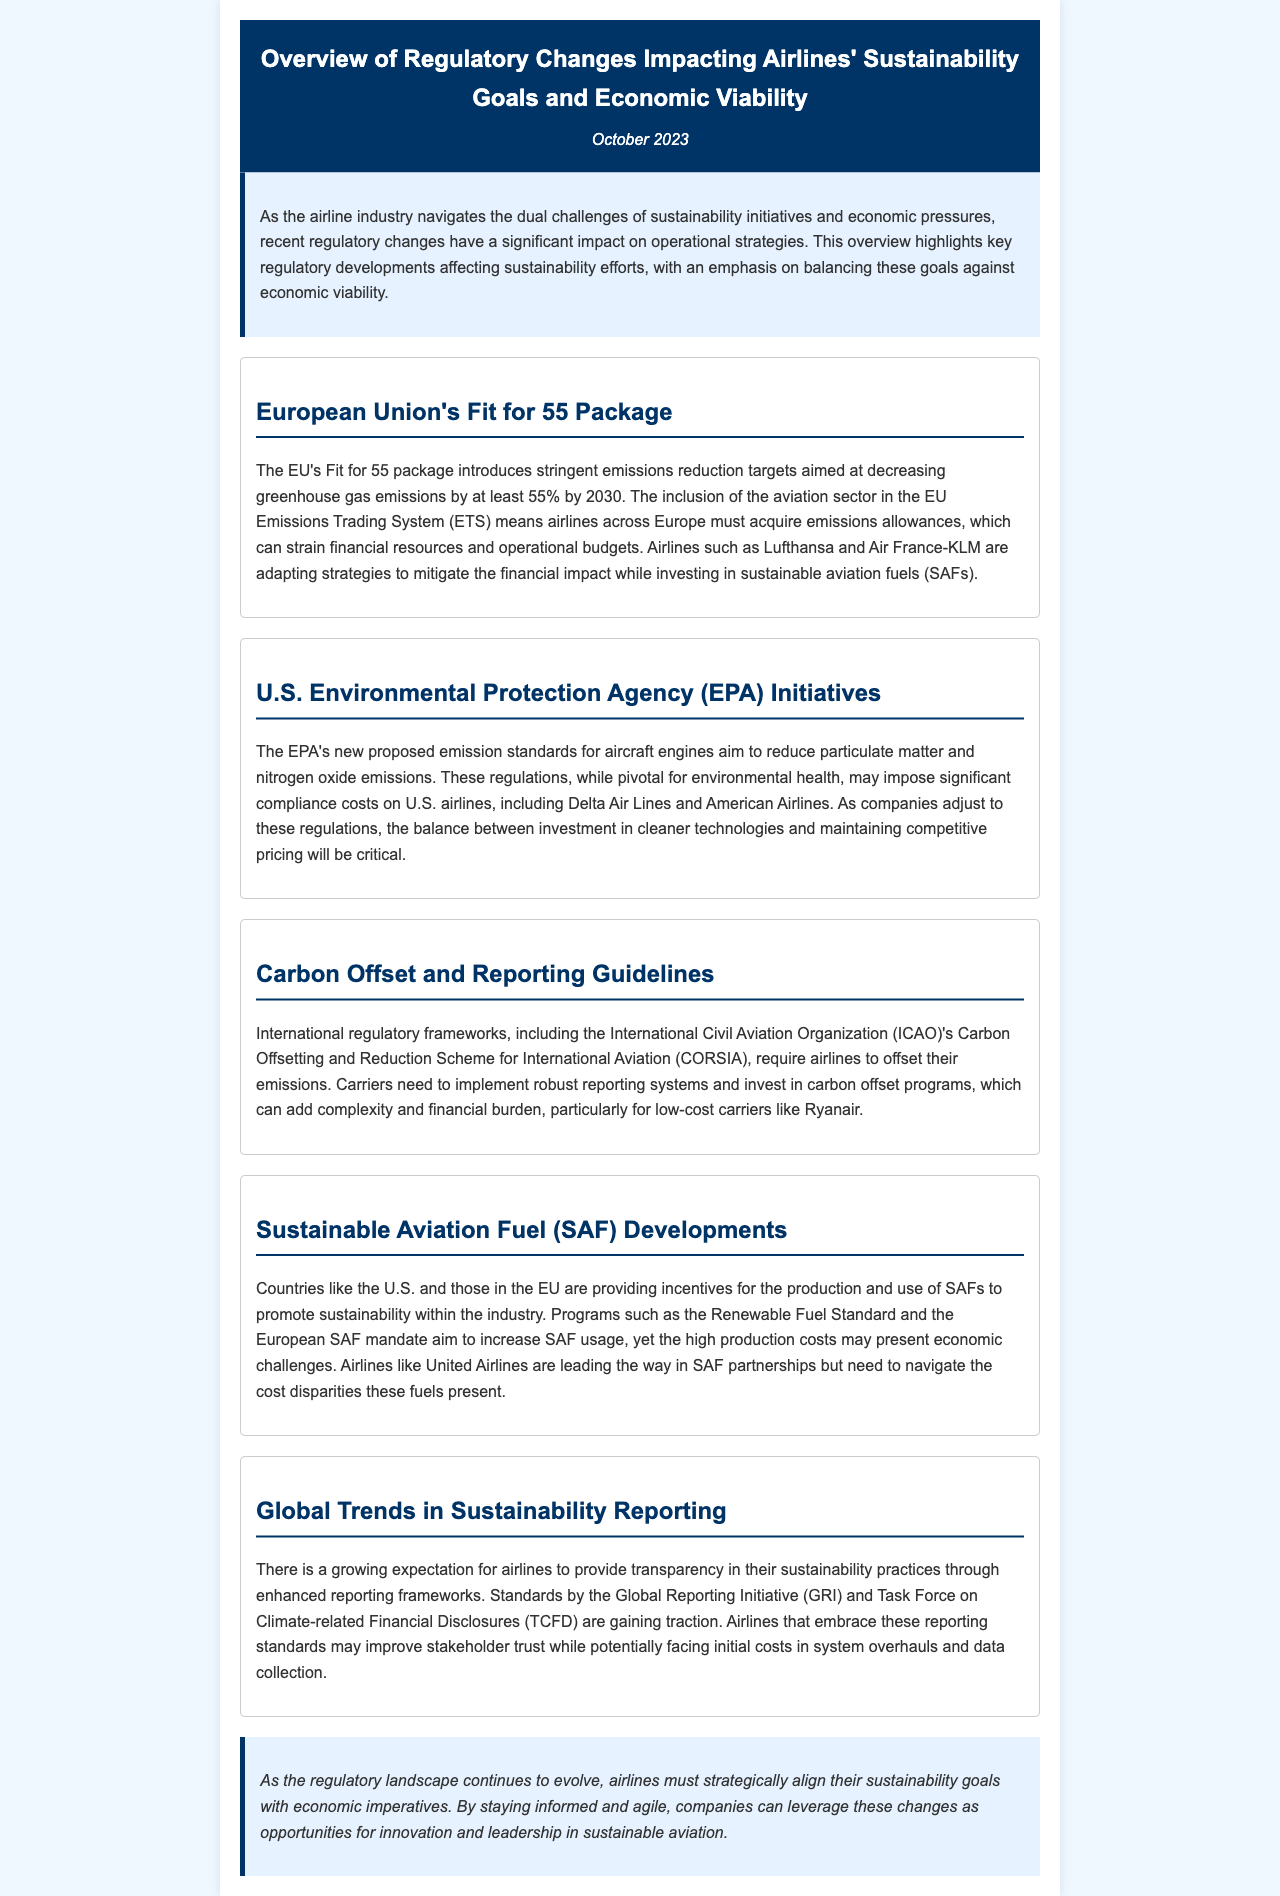What is the main goal of the EU's Fit for 55 package? The package aims at decreasing greenhouse gas emissions by at least 55% by 2030.
Answer: decreasing greenhouse gas emissions by at least 55% by 2030 Which airlines are mentioned as adapting to the EU Emissions Trading System? Lufthansa and Air France-KLM are noted for adapting strategies to mitigate financial impacts.
Answer: Lufthansa and Air France-KLM What is the proposed EPA initiative targeting? The EPA's initiative targets reducing particulate matter and nitrogen oxide emissions from aircraft engines.
Answer: reducing particulate matter and nitrogen oxide emissions Which international regulatory framework requires airlines to offset their emissions? CORSIA (Carbon Offsetting and Reduction Scheme for International Aviation) is the framework mentioned.
Answer: CORSIA What is one consequence of the regulations requiring robust reporting systems for airlines? Implementing robust reporting systems adds complexity and financial burden, particularly for low-cost carriers.
Answer: adds complexity and financial burden What do the Renewable Fuel Standard and European SAF mandate aim to encourage? They aim to promote the production and use of sustainable aviation fuels (SAFs).
Answer: production and use of SAFs Which organization’s standards are gaining traction for sustainability reporting? The Global Reporting Initiative (GRI) standards are gaining traction.
Answer: Global Reporting Initiative (GRI) What should airlines embrace to improve stakeholder trust? Airlines that embrace enhanced reporting frameworks may improve stakeholder trust.
Answer: enhanced reporting frameworks 